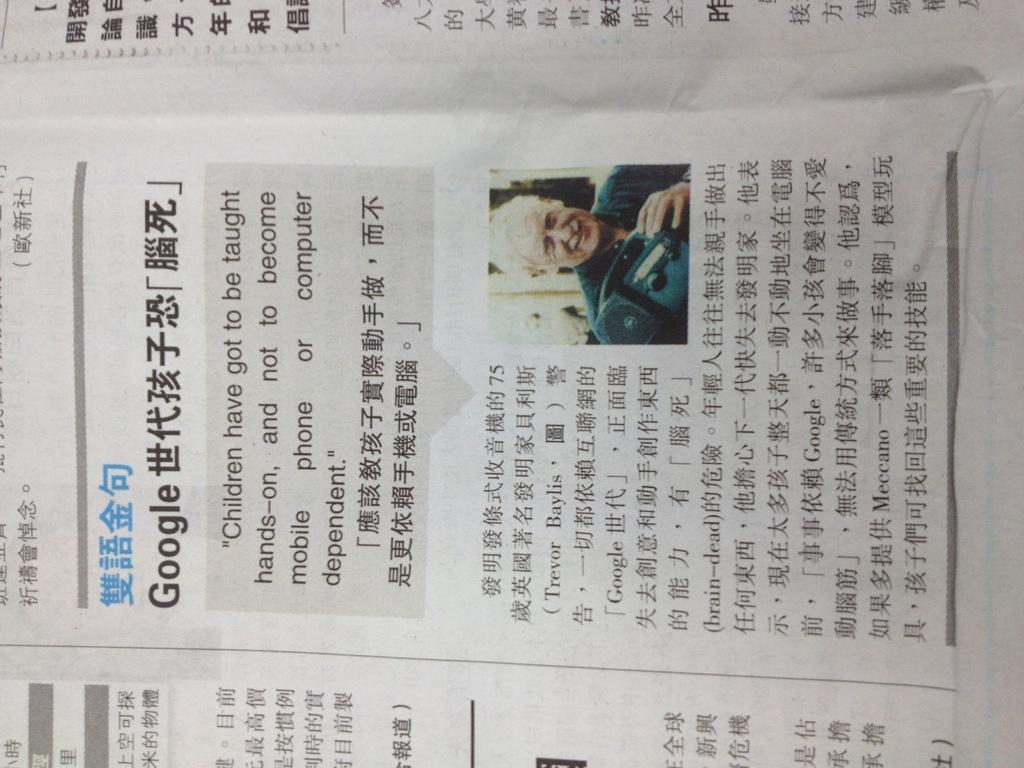What is present on the paper in the image? There is a paper in the image, and it has text and a photograph of a man on it. Can you describe the content of the text on the paper? Unfortunately, the specific content of the text cannot be determined from the image. What is the subject of the photograph on the paper? The photograph on the paper is of a man. How many boys are playing with the crate in the image? There are no boys or crates present in the image. 